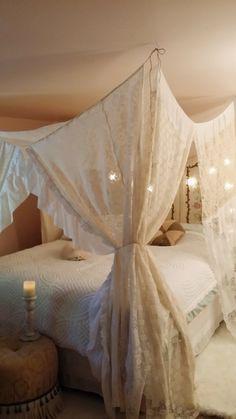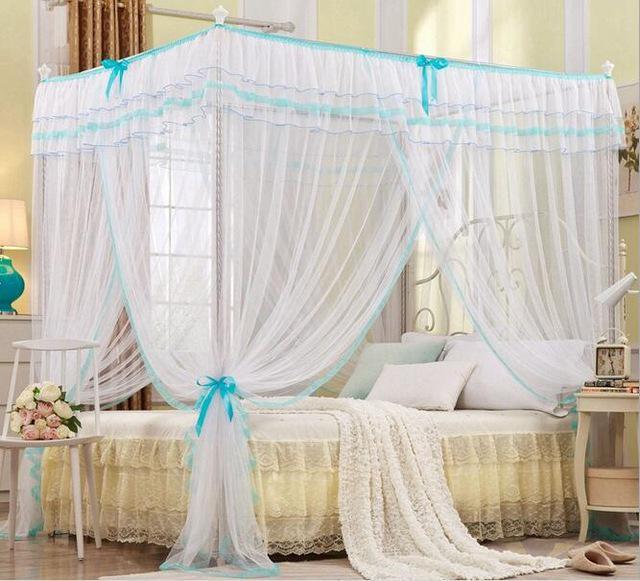The first image is the image on the left, the second image is the image on the right. Assess this claim about the two images: "The left and right image contains the same number of square open lace canopies.". Correct or not? Answer yes or no. Yes. The first image is the image on the left, the second image is the image on the right. Analyze the images presented: Is the assertion "One image shows a sheer pinkish canopy with a ruffled border around the top, on a four-post bed." valid? Answer yes or no. No. 